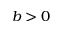<formula> <loc_0><loc_0><loc_500><loc_500>b > 0</formula> 